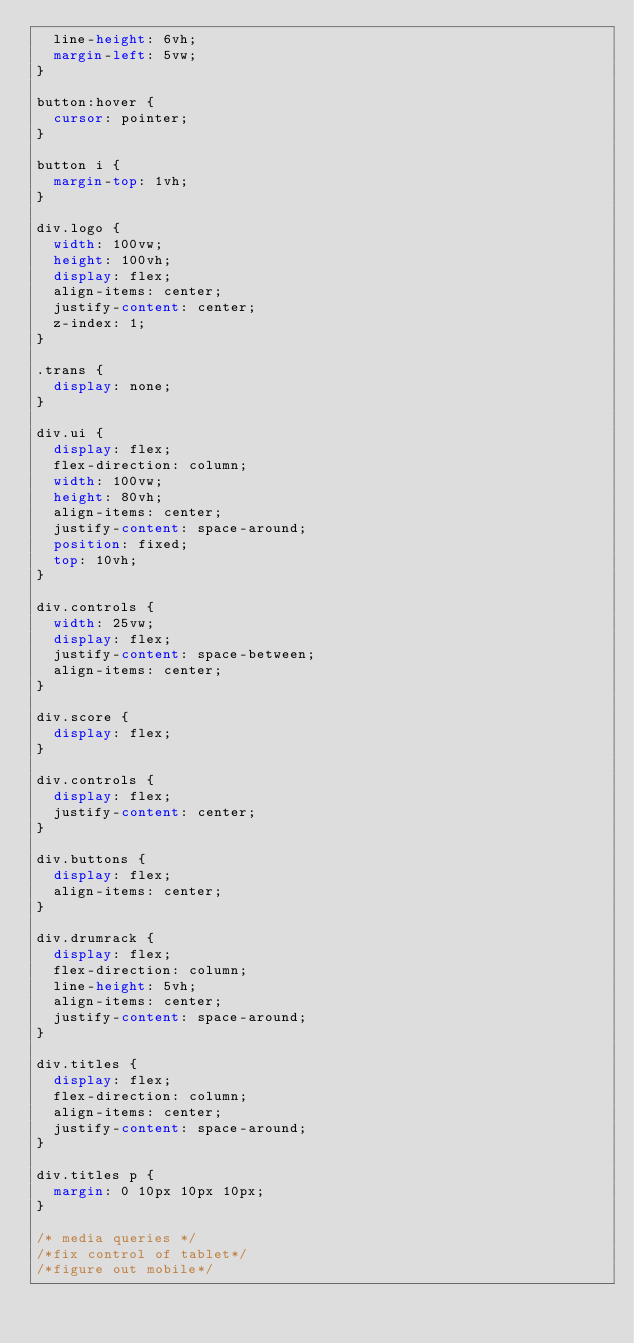<code> <loc_0><loc_0><loc_500><loc_500><_CSS_>  line-height: 6vh;
  margin-left: 5vw;
}

button:hover {
  cursor: pointer;
}

button i {
  margin-top: 1vh;
}

div.logo {
  width: 100vw;
  height: 100vh;
  display: flex;
  align-items: center;
  justify-content: center;
  z-index: 1;
}

.trans {
  display: none;
}

div.ui {
  display: flex;
  flex-direction: column;
  width: 100vw;
  height: 80vh;
  align-items: center;
  justify-content: space-around;
  position: fixed;
  top: 10vh;
}

div.controls {
  width: 25vw;
  display: flex;
  justify-content: space-between;
  align-items: center;
}

div.score {
  display: flex;
}

div.controls {
  display: flex;
  justify-content: center;
}

div.buttons {
  display: flex;
  align-items: center;
}

div.drumrack {
  display: flex;
  flex-direction: column;
  line-height: 5vh;
  align-items: center;
  justify-content: space-around;
}

div.titles {
  display: flex;
  flex-direction: column;
  align-items: center;
  justify-content: space-around;
}

div.titles p {
  margin: 0 10px 10px 10px;
}

/* media queries */
/*fix control of tablet*/
/*figure out mobile*/
</code> 